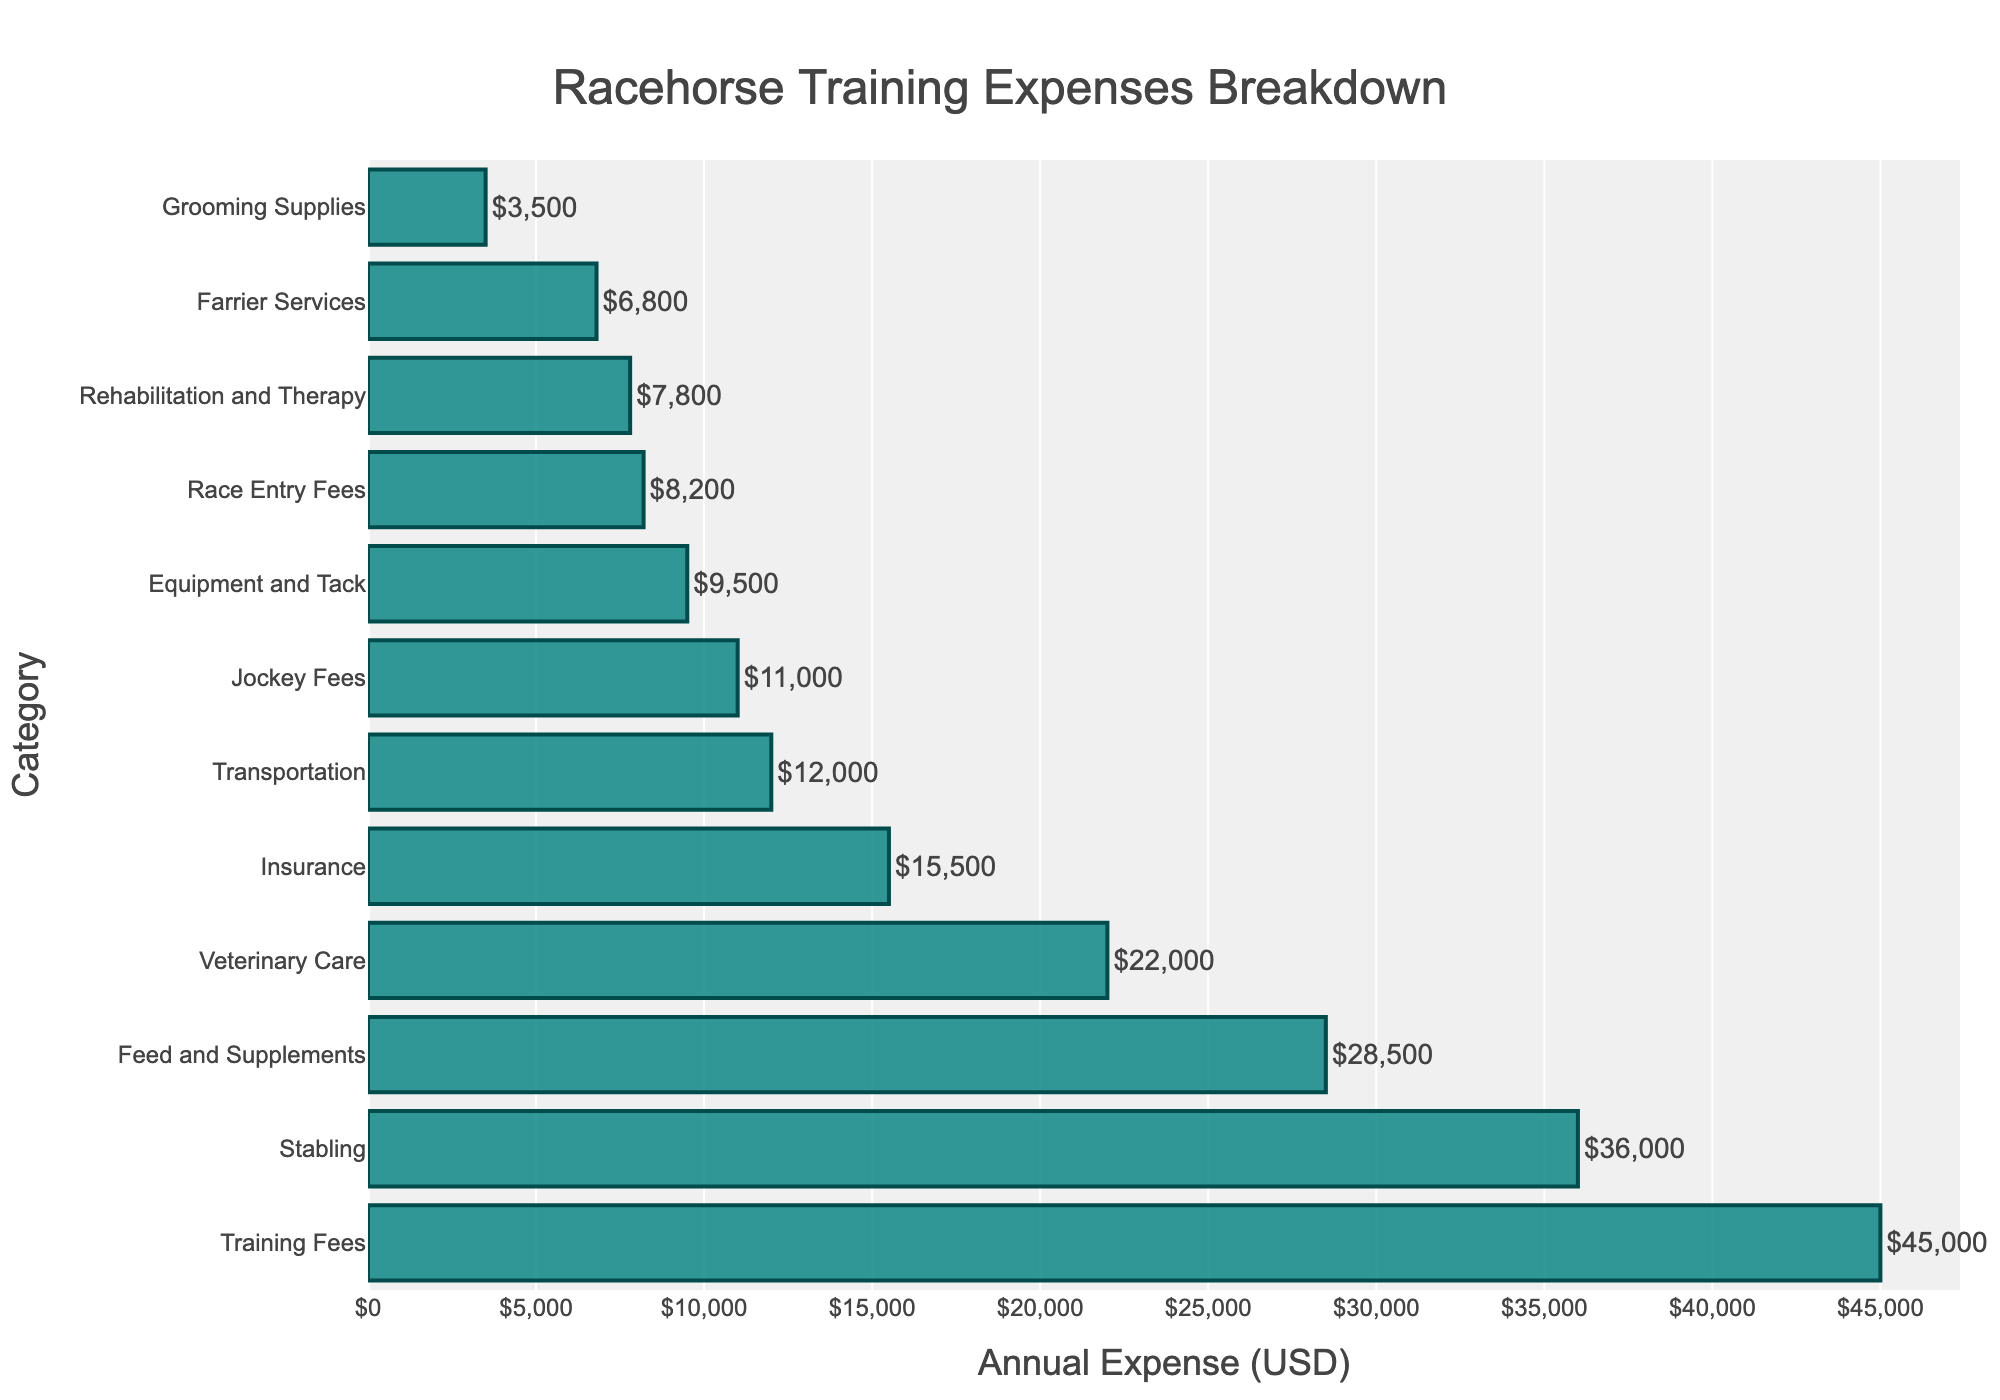Which category has the highest annual expense? The figure shows a horizontal bar chart where the category with the longest bar represents the highest annual expense. The "Training Fees" bar is the longest.
Answer: Training Fees What is the total annual expense for Feed and Supplements and Veterinary Care combined? To find the total annual expense, add the individual expenses for "Feed and Supplements" and "Veterinary Care". According to the figure, these values are $28,500 and $22,000 respectively. $28,500 + $22,000 = $50,500.
Answer: $50,500 Which categories have annual expenses less than $10,000? Categories with shorter bars represent expenses less than $10,000. The categories meeting this criterion are "Farrier Services", "Equipment and Tack", "Race Entry Fees", "Jockey Fees", "Grooming Supplies", and "Rehabilitation and Therapy".
Answer: Farrier Services, Equipment and Tack, Race Entry Fees, Jockey Fees, Grooming Supplies, Rehabilitation and Therapy How much higher is the expense for Stabling compared to Transportation? The expenses for "Stabling" and "Transportation" can be found directly in the figure: $36,000 and $12,000 respectively. The difference is $36,000 - $12,000 = $24,000.
Answer: $24,000 What is the average annual expense for Grooming Supplies, Farrier Services, and Rehabilitation and Therapy? Add the annual expenses for "Grooming Supplies" ($3,500), "Farrier Services" ($6,800), and "Rehabilitation and Therapy" ($7,800), then divide by the number of categories (3). Average = ($3,500 + $6,800 + $7,800) / 3 ≈ $6,033.33.
Answer: $6,033.33 Which category appears to have an annual expense closest to $15,000? Review the lengths of the bars and locate the one closest to the $15,000 mark on the x-axis. "Insurance" has an expense of $15,500, which is nearest to $15,000.
Answer: Insurance Are the annual expenses for Feed and Supplements and Jockey Fees greater than $20,000 combined? Sum the expenses for "Feed and Supplements" ($28,500) and "Jockey Fees" ($11,000), then check if this is greater than $20,000. $28,500 + $11,000 = $39,500, which is greater than $20,000.
Answer: Yes What's the difference between the highest and lowest annual expenses shown in the chart? Identify the highest (Training Fees: $45,000) and the lowest (Grooming Supplies: $3,500) annual expenses. Calculate the difference: $45,000 - $3,500 = $41,500.
Answer: $41,500 